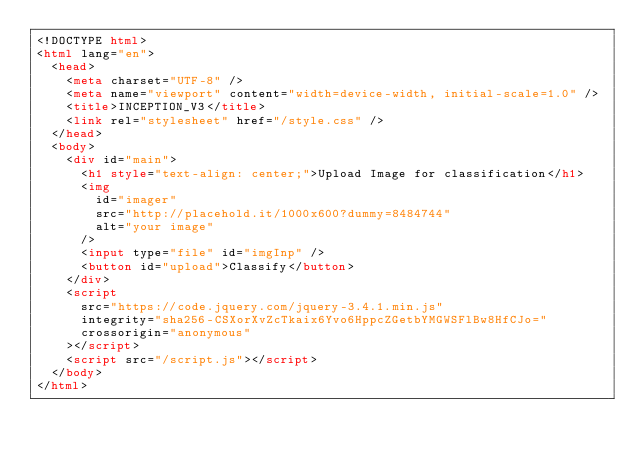<code> <loc_0><loc_0><loc_500><loc_500><_HTML_><!DOCTYPE html>
<html lang="en">
  <head>
    <meta charset="UTF-8" />
    <meta name="viewport" content="width=device-width, initial-scale=1.0" />
    <title>INCEPTION_V3</title>
    <link rel="stylesheet" href="/style.css" />
  </head>
  <body>
    <div id="main">
      <h1 style="text-align: center;">Upload Image for classification</h1>
      <img
        id="imager"
        src="http://placehold.it/1000x600?dummy=8484744"
        alt="your image"
      />
      <input type="file" id="imgInp" />
      <button id="upload">Classify</button>
    </div>
    <script
      src="https://code.jquery.com/jquery-3.4.1.min.js"
      integrity="sha256-CSXorXvZcTkaix6Yvo6HppcZGetbYMGWSFlBw8HfCJo="
      crossorigin="anonymous"
    ></script>
    <script src="/script.js"></script>
  </body>
</html>
</code> 